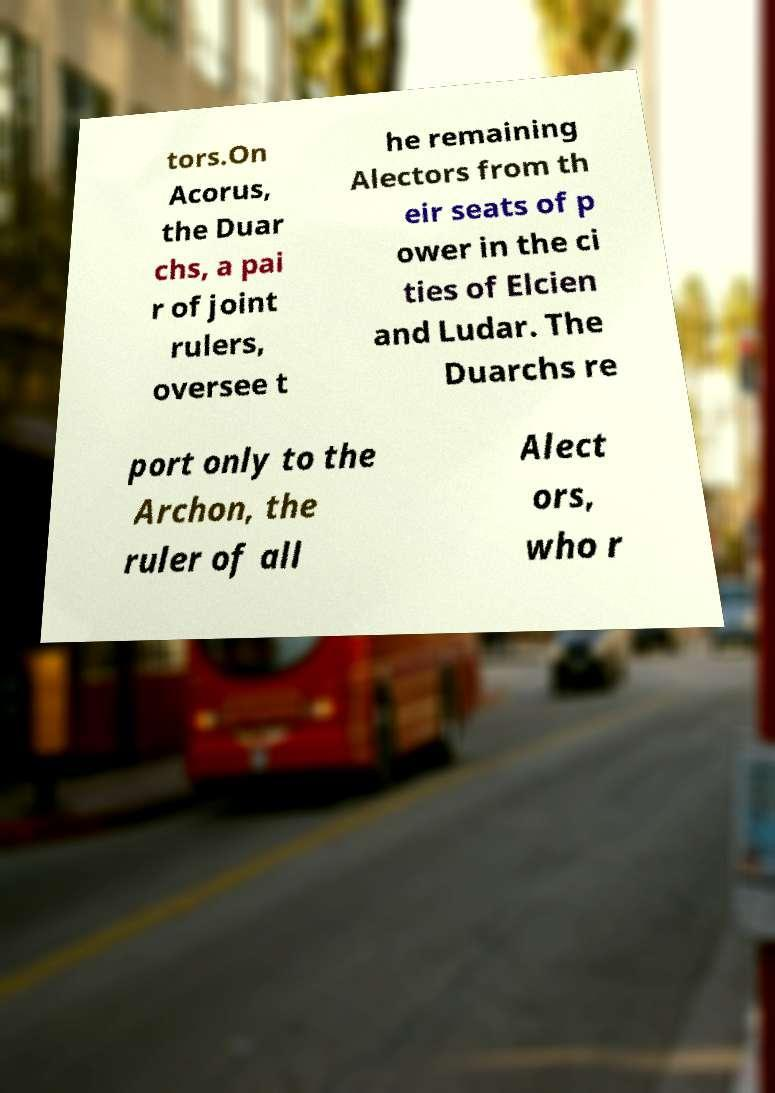I need the written content from this picture converted into text. Can you do that? tors.On Acorus, the Duar chs, a pai r of joint rulers, oversee t he remaining Alectors from th eir seats of p ower in the ci ties of Elcien and Ludar. The Duarchs re port only to the Archon, the ruler of all Alect ors, who r 